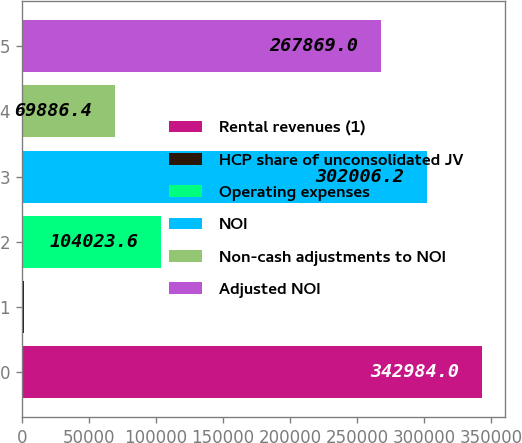<chart> <loc_0><loc_0><loc_500><loc_500><bar_chart><fcel>Rental revenues (1)<fcel>HCP share of unconsolidated JV<fcel>Operating expenses<fcel>NOI<fcel>Non-cash adjustments to NOI<fcel>Adjusted NOI<nl><fcel>342984<fcel>1612<fcel>104024<fcel>302006<fcel>69886.4<fcel>267869<nl></chart> 